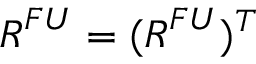Convert formula to latex. <formula><loc_0><loc_0><loc_500><loc_500>R ^ { F U } = ( R ^ { F U } ) ^ { T }</formula> 